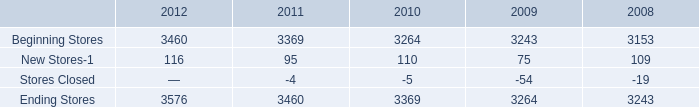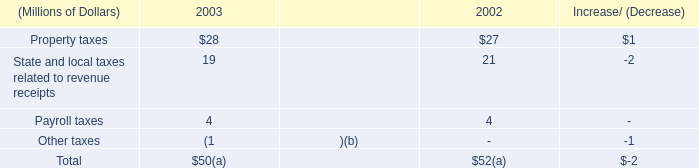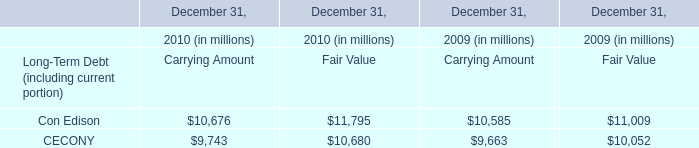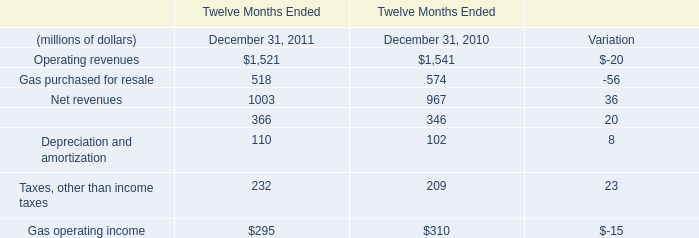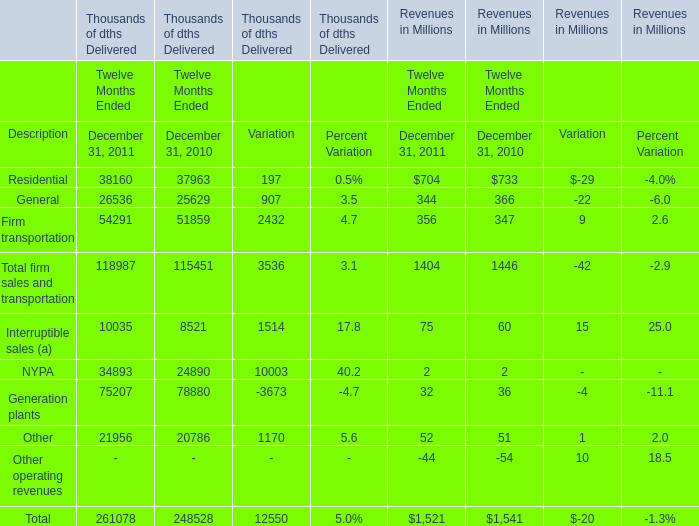What will Revenues of Firm transportation be like in 2012 if it develops with the same increasing rate as current? (in million) 
Computations: (356 * (1 + ((356 - 347) / 347)))
Answer: 365.23343. 